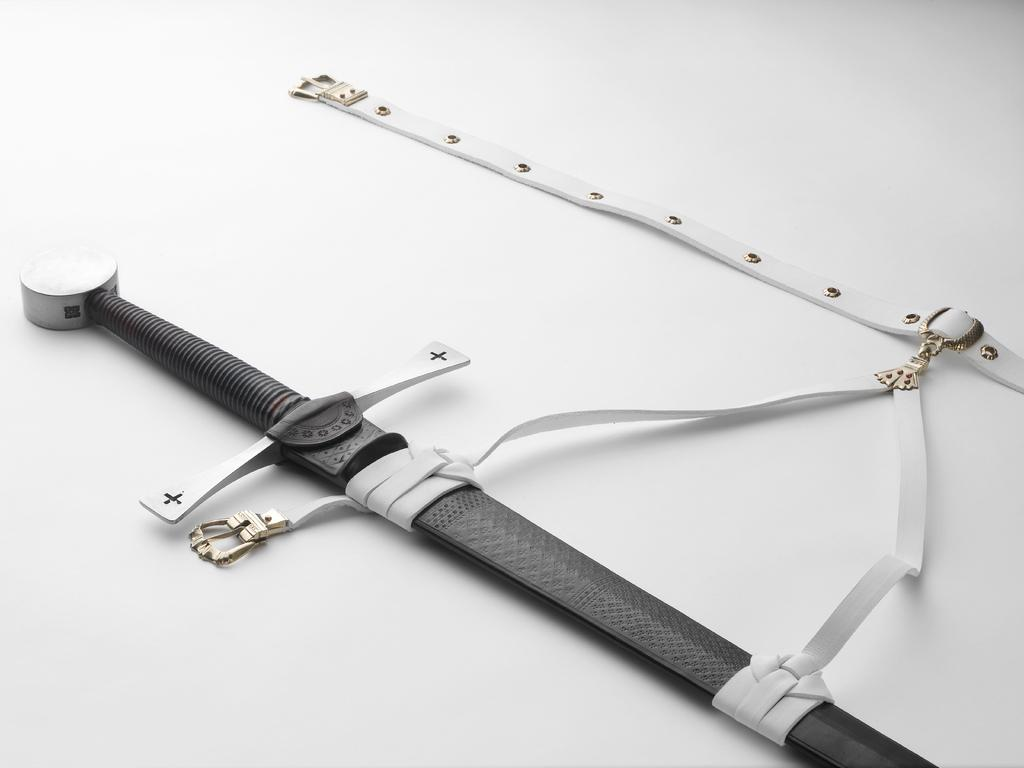What object can be seen in the image that is typically used as a weapon? There is a dagger in the image. What other object is visible in the image that is often used for holding up pants? There is a belt in the image. On what surface are the dagger and belt placed? The dagger and belt are on a white surface. What type of theory is being discussed in the image? There is no discussion or mention of any theory in the image; it only features a dagger and a belt on a white surface. Can you explain how the drain is connected to the objects in the image? There is no drain present in the image; it only features a dagger and a belt on a white surface. 